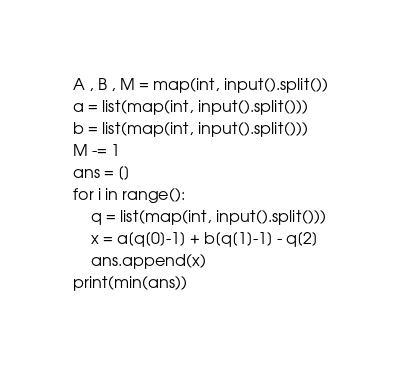Convert code to text. <code><loc_0><loc_0><loc_500><loc_500><_Python_>A , B , M = map(int, input().split())
a = list(map(int, input().split()))
b = list(map(int, input().split()))
M -= 1
ans = []
for i in range():
    q = list(map(int, input().split()))
    x = a[q[0]-1] + b[q[1]-1] - q[2]
    ans.append(x)
print(min(ans))</code> 